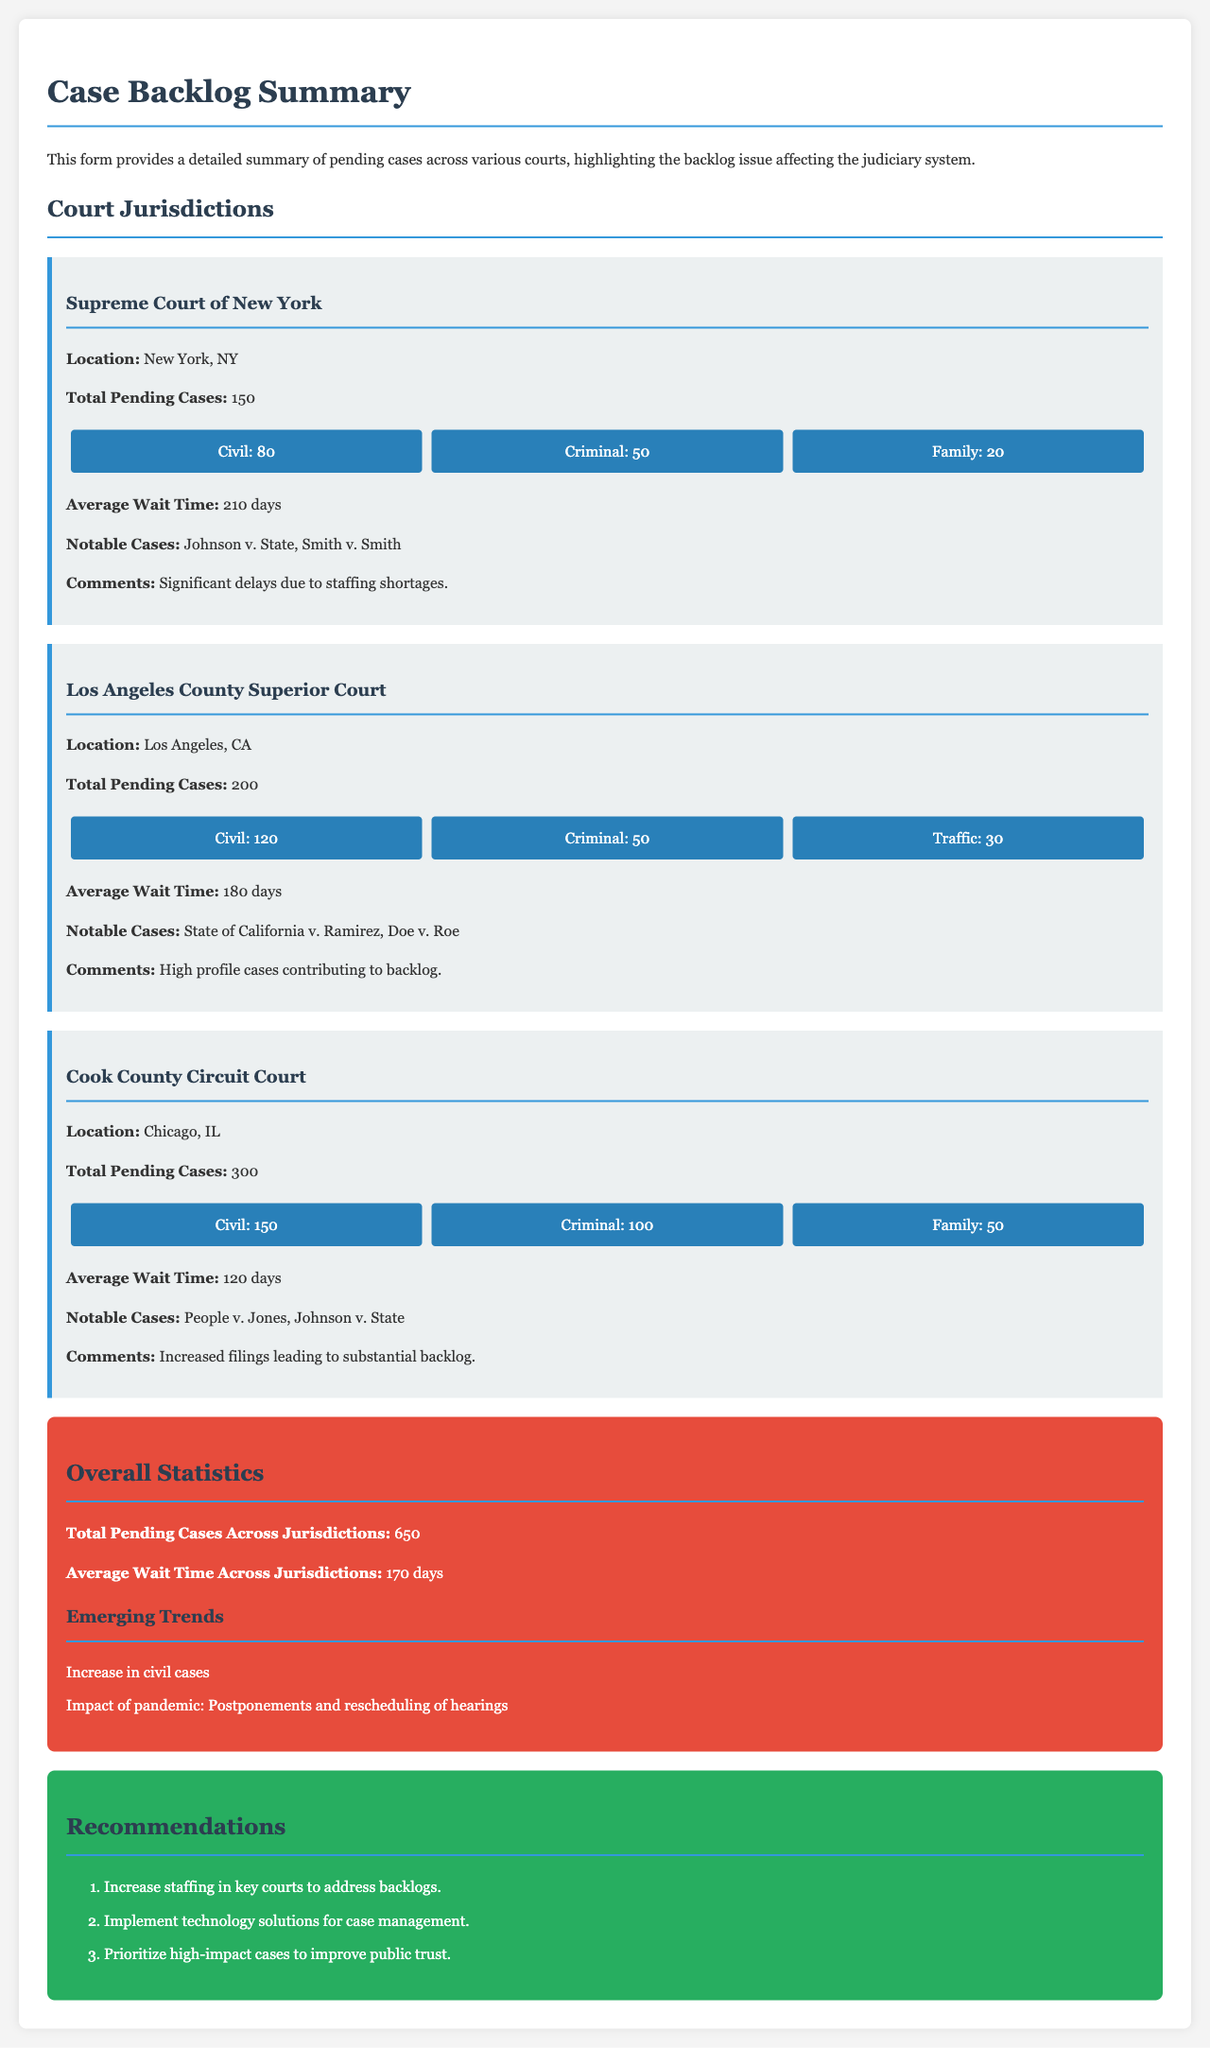What is the total number of pending cases in the Supreme Court of New York? The document states that the total pending cases in the Supreme Court of New York is 150.
Answer: 150 What is the average wait time for cases in Cook County Circuit Court? The average wait time for cases in Cook County Circuit Court is provided as 120 days.
Answer: 120 days What notable case is mentioned for Los Angeles County Superior Court? The notable cases for Los Angeles County Superior Court include "State of California v. Ramirez."
Answer: State of California v. Ramirez How many total pending cases are reported across all jurisdictions? The document reports a total of 650 pending cases across all jurisdictions.
Answer: 650 Which court has the highest number of pending cases? Cook County Circuit Court has the highest number of pending cases at 300.
Answer: Cook County Circuit Court What are the two emerging trends identified in the overall statistics section? The document mentions an increase in civil cases and the impact of the pandemic.
Answer: Increase in civil cases, impact of pandemic What is one of the recommendations made in the document? One recommendation includes increasing staffing in key courts to address backlogs.
Answer: Increase staffing in key courts What is the average wait time across jurisdictions as per the overall statistics? The average wait time across jurisdictions is mentioned as 170 days.
Answer: 170 days 